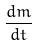<formula> <loc_0><loc_0><loc_500><loc_500>\frac { d m } { d t }</formula> 